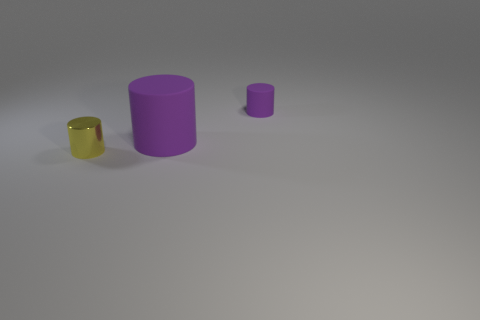Are there any other things that are the same shape as the large purple thing?
Give a very brief answer. Yes. There is a large cylinder; how many matte cylinders are behind it?
Ensure brevity in your answer.  1. Are there an equal number of purple things to the right of the large purple rubber cylinder and big purple rubber objects?
Offer a terse response. Yes. Is the tiny purple object made of the same material as the large purple cylinder?
Offer a terse response. Yes. How big is the object that is both in front of the tiny purple rubber cylinder and on the right side of the tiny shiny thing?
Make the answer very short. Large. How many rubber objects have the same size as the shiny object?
Offer a very short reply. 1. There is a matte cylinder that is in front of the small thing that is right of the small yellow object; what is its size?
Your answer should be very brief. Large. There is a purple object on the right side of the big rubber cylinder; is it the same shape as the purple object in front of the small matte cylinder?
Offer a terse response. Yes. What color is the object that is behind the tiny metal object and in front of the tiny rubber cylinder?
Ensure brevity in your answer.  Purple. Is there another small metallic cylinder of the same color as the tiny metallic cylinder?
Ensure brevity in your answer.  No. 